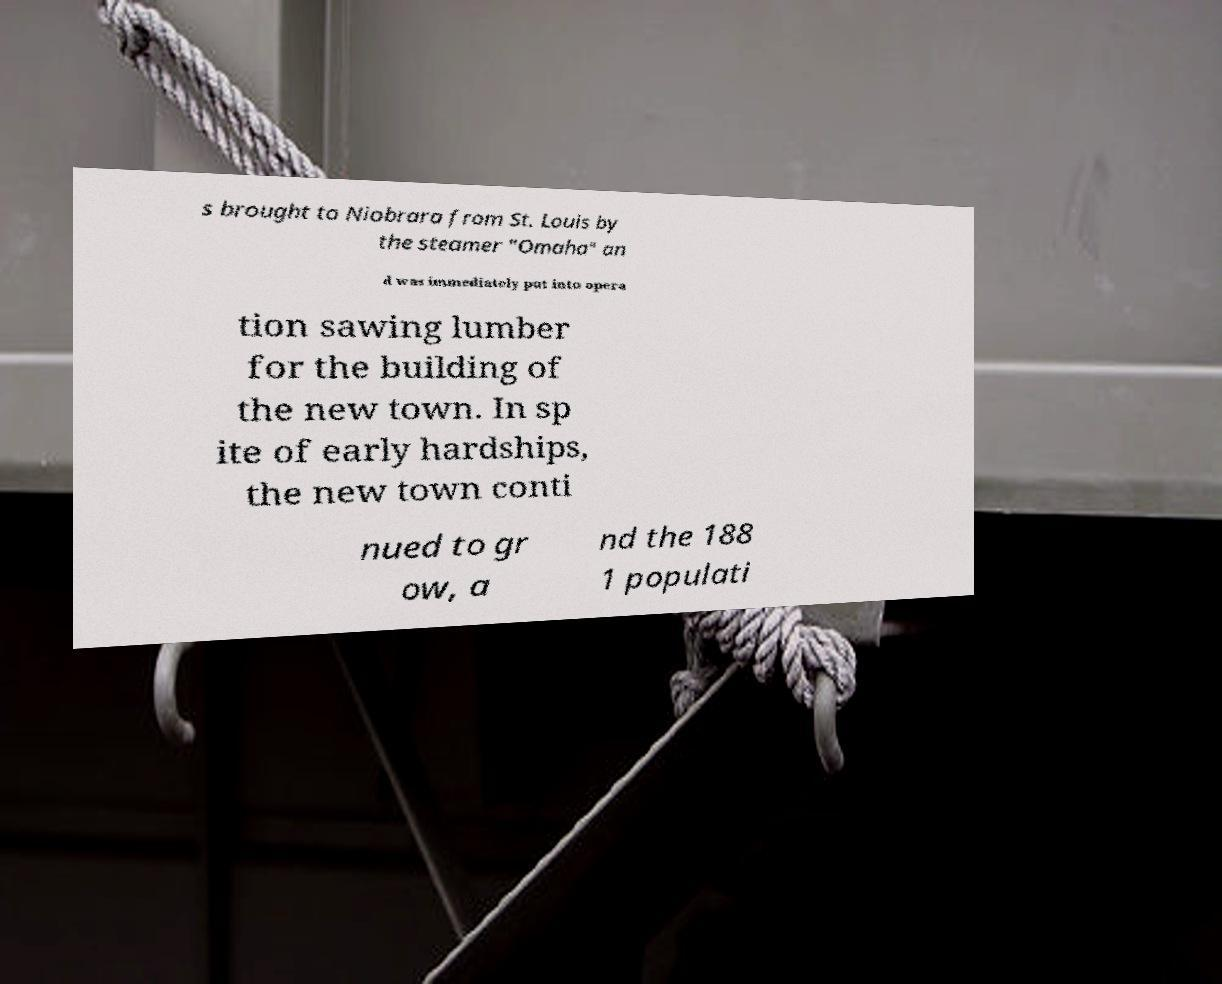There's text embedded in this image that I need extracted. Can you transcribe it verbatim? s brought to Niobrara from St. Louis by the steamer "Omaha" an d was immediately put into opera tion sawing lumber for the building of the new town. In sp ite of early hardships, the new town conti nued to gr ow, a nd the 188 1 populati 